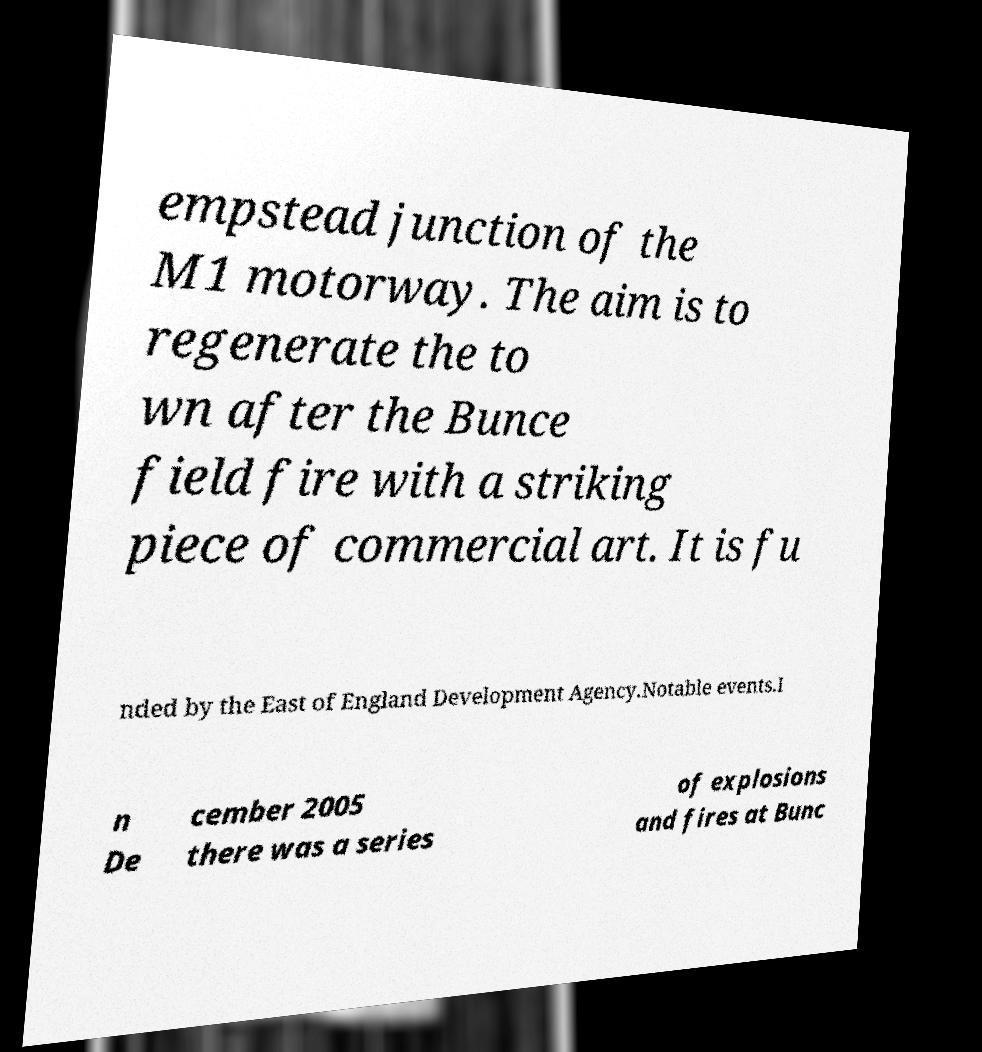Can you accurately transcribe the text from the provided image for me? empstead junction of the M1 motorway. The aim is to regenerate the to wn after the Bunce field fire with a striking piece of commercial art. It is fu nded by the East of England Development Agency.Notable events.I n De cember 2005 there was a series of explosions and fires at Bunc 